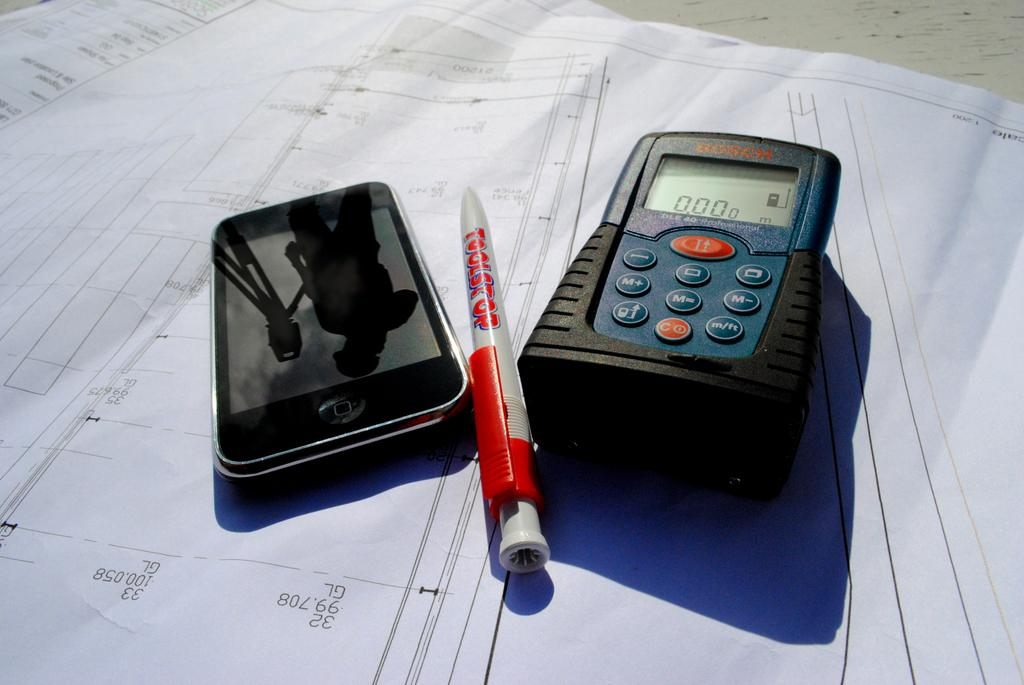What electronic device is visible in the image? There is a multimeter in the image. What is the purpose of the pen in the image? The pen is likely used for writing or drawing. What can be seen in the background of the image? There are papers and a white surface in the background of the image. How many children are getting a haircut in the image? There are no children or haircuts present in the image. What is the name of the person the pen is crushing on in the image? There is no mention of a crush or a person in the image. 